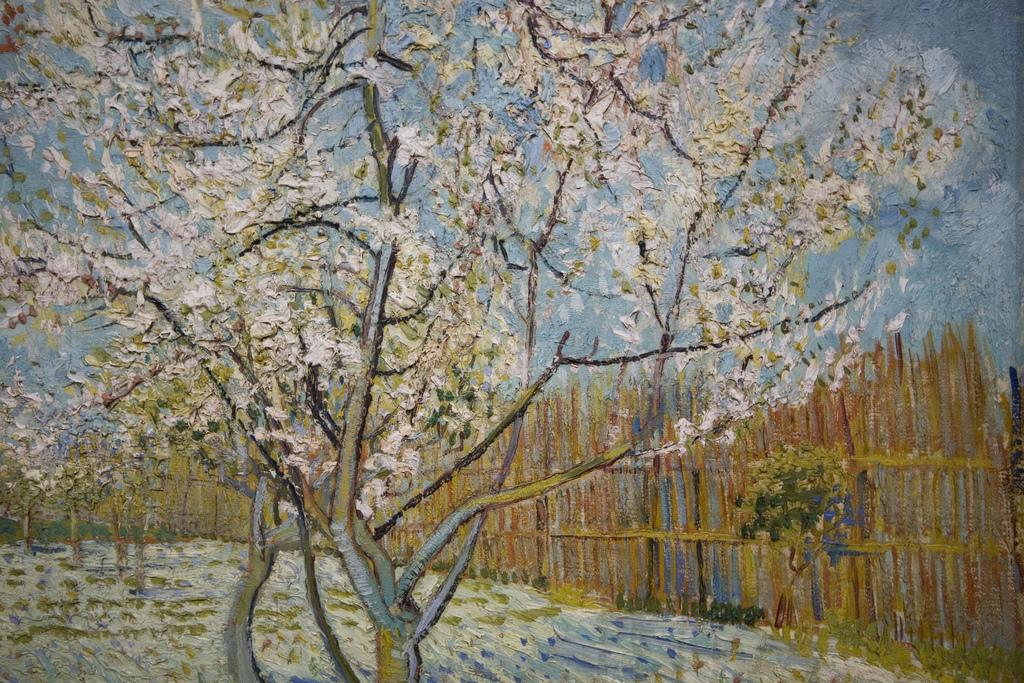What is the main subject of the image? There is a painting in the image. What elements are present in the painting? The painting contains a tree, fencing, sky, and grass. Can you see a cub playing in the grass in the painting? There is: There is no cub present in the painting; it only contains a tree, fencing, sky, and grass. Is there a recess in the painting? The concept of a recess does not apply to a painting, as it is a two-dimensional representation and not a physical space. --- Facts: 1. There is a person sitting on a bench in the image. 2. The person is reading a book. 3. There is a tree behind the bench. 4. The sky is visible in the image. 5. There is a path leading to the bench. Absurd Topics: elephant, volcano, dance Conversation: What is the person in the image doing? The person is sitting on a bench and reading a book. What is located behind the bench in the image? There is a tree behind the bench. What can be seen in the sky in the image? The sky is visible in the image. What type of path is present in the image? There is a path leading to the bench. Reasoning: Let's think step by step in order to produce the conversation. We start by identifying the main subject of the image, which is the person sitting on the bench. Then, we describe the person's activity, which is reading a book. Next, we identify the objects and elements surrounding the person, such as the tree, sky, and path. Each question is designed to elicit a specific detail about the image that is known from the provided facts. Absurd Question/Answer: Can you see an elephant walking on the path in the image? There is no elephant present in the image; it only contains a person sitting on a bench, a tree, sky, and a path. Is there a volcano visible in the image? There is no volcano present in the image; it only contains a person sitting on a bench, a tree, sky, and a path. 